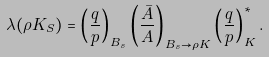<formula> <loc_0><loc_0><loc_500><loc_500>\lambda ( \rho K _ { S } ) = \left ( \frac { q } { p } \right ) _ { B _ { s } } \left ( \frac { \bar { A } } { A } \right ) _ { B _ { s } \rightarrow \rho K } \left ( \frac { q } { p } \right ) _ { K } ^ { * } .</formula> 